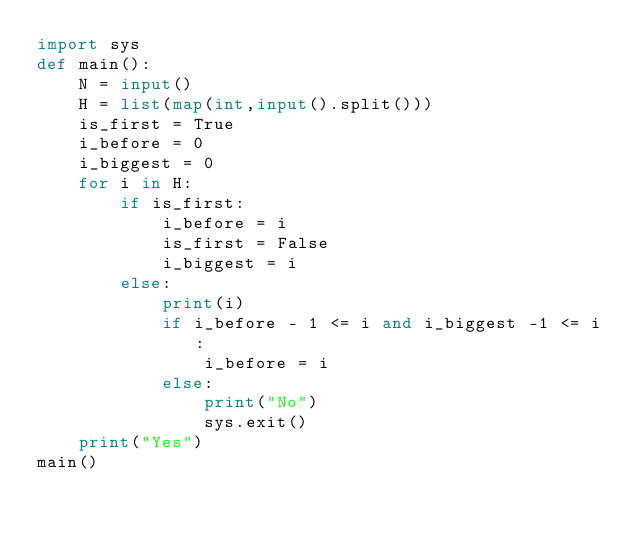Convert code to text. <code><loc_0><loc_0><loc_500><loc_500><_Python_>import sys
def main():
    N = input()
    H = list(map(int,input().split()))
    is_first = True
    i_before = 0
    i_biggest = 0
    for i in H:
        if is_first:
            i_before = i
            is_first = False
            i_biggest = i
        else:
            print(i)
            if i_before - 1 <= i and i_biggest -1 <= i:
                i_before = i
            else:
                print("No")
                sys.exit()
    print("Yes")
main()</code> 